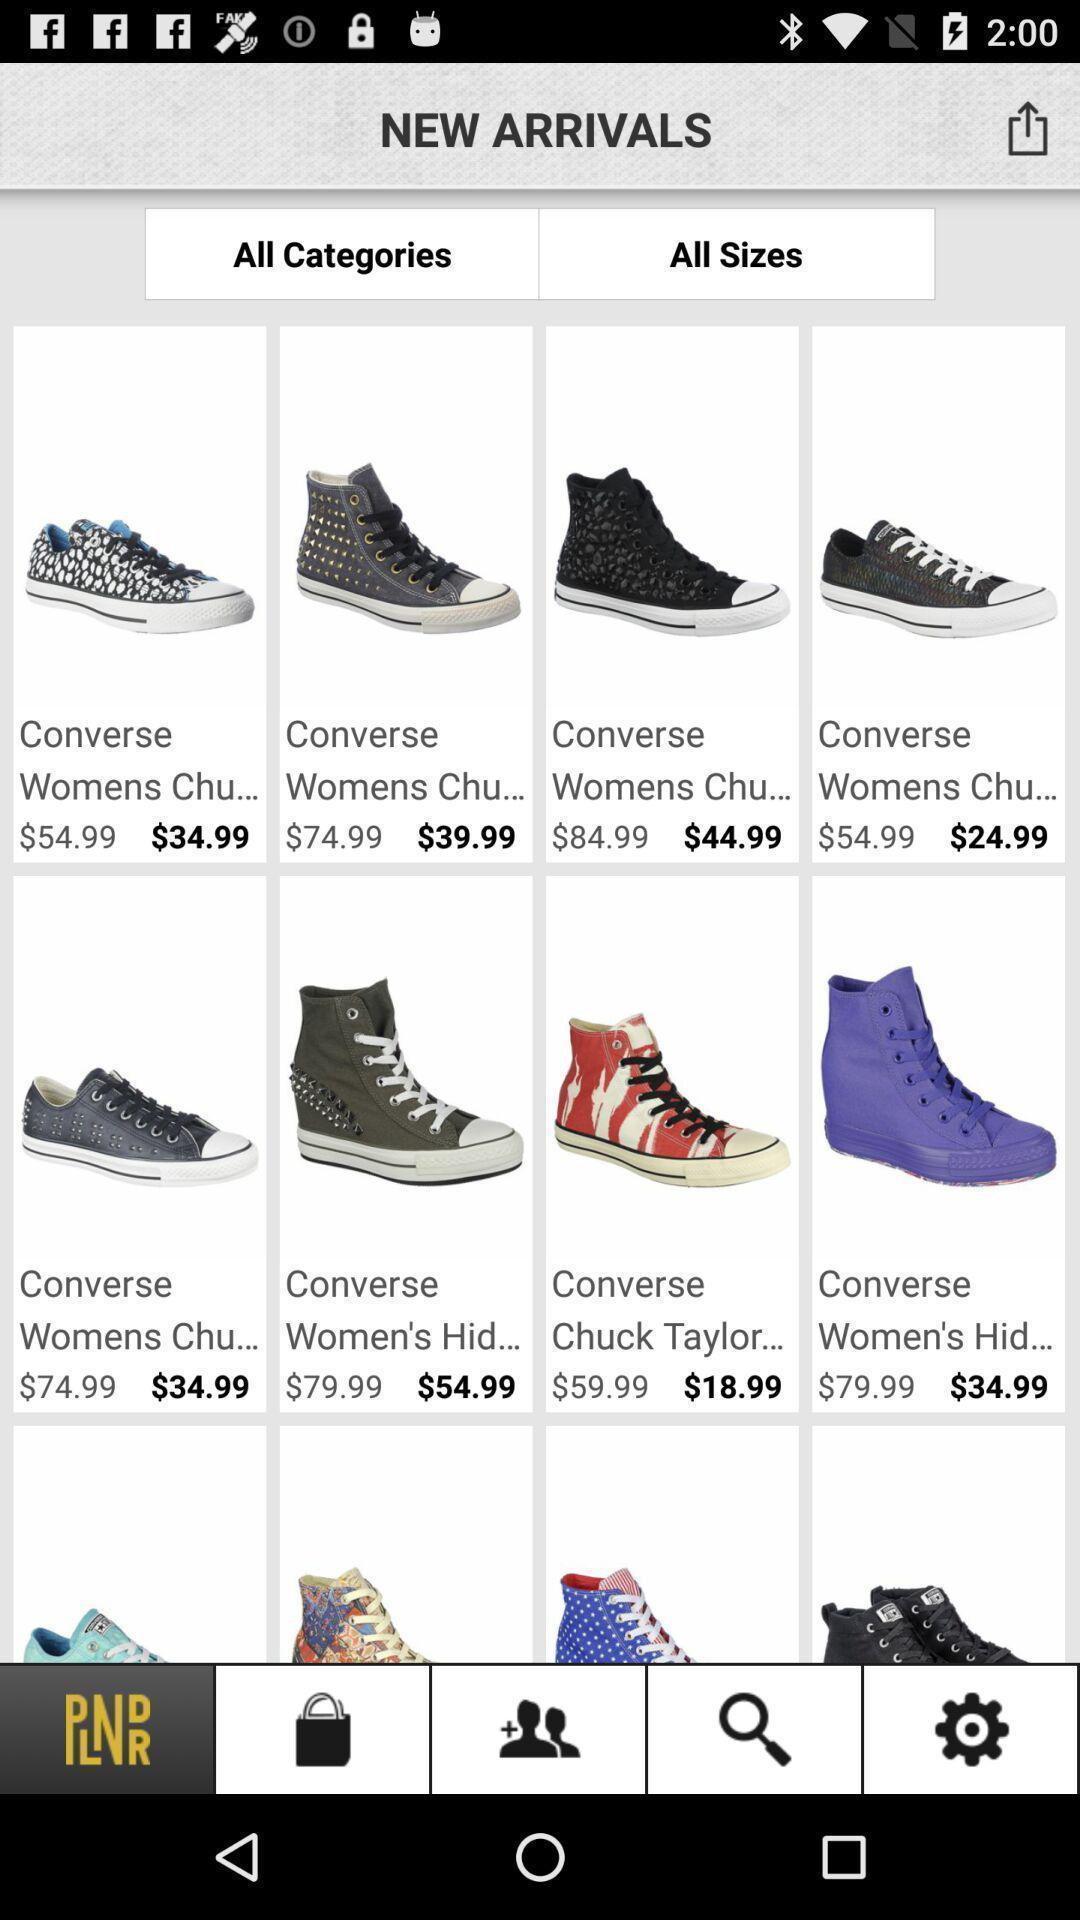What details can you identify in this image? Screen shows new arrivals in a shopping app. 